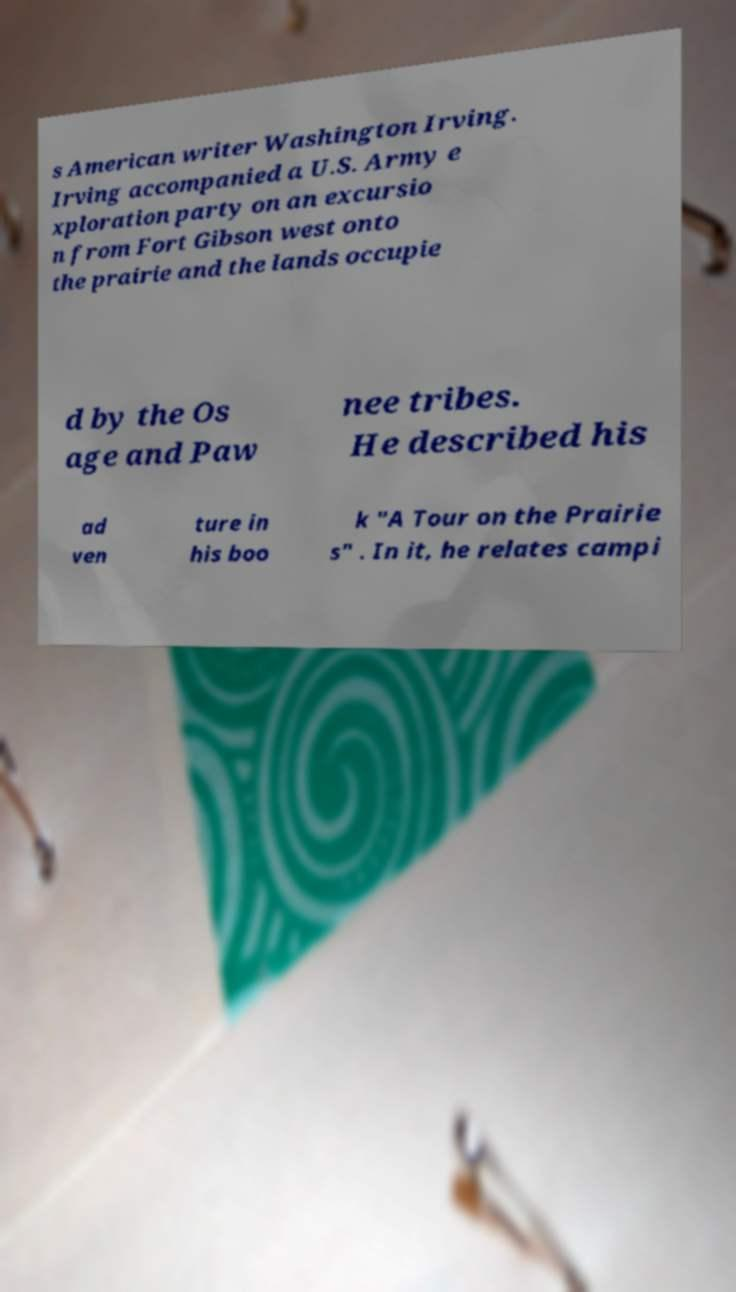Could you extract and type out the text from this image? s American writer Washington Irving. Irving accompanied a U.S. Army e xploration party on an excursio n from Fort Gibson west onto the prairie and the lands occupie d by the Os age and Paw nee tribes. He described his ad ven ture in his boo k "A Tour on the Prairie s" . In it, he relates campi 